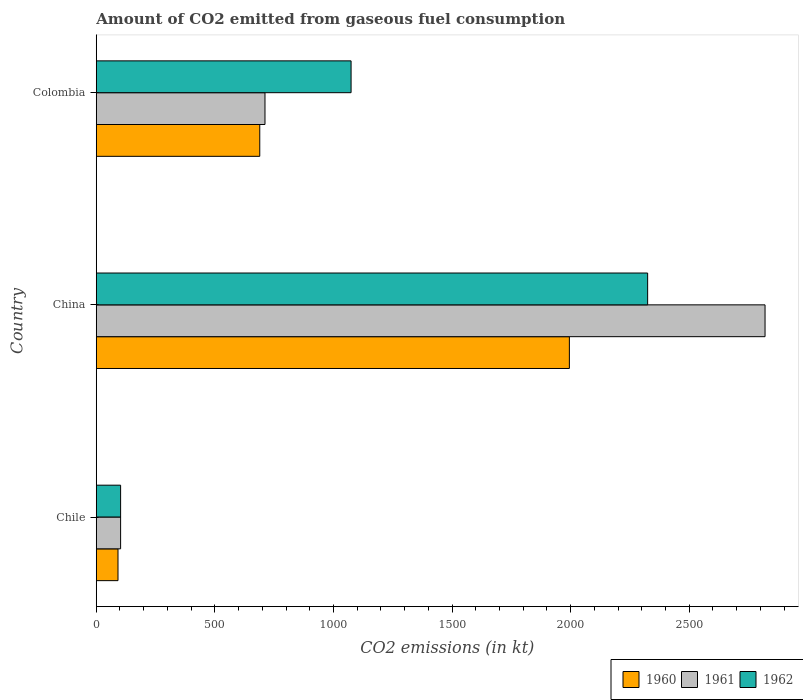How many different coloured bars are there?
Keep it short and to the point. 3. Are the number of bars on each tick of the Y-axis equal?
Your answer should be very brief. Yes. How many bars are there on the 1st tick from the bottom?
Offer a terse response. 3. In how many cases, is the number of bars for a given country not equal to the number of legend labels?
Your answer should be very brief. 0. What is the amount of CO2 emitted in 1962 in China?
Provide a short and direct response. 2324.88. Across all countries, what is the maximum amount of CO2 emitted in 1960?
Offer a terse response. 1994.85. Across all countries, what is the minimum amount of CO2 emitted in 1962?
Your answer should be compact. 102.68. In which country was the amount of CO2 emitted in 1962 maximum?
Your response must be concise. China. In which country was the amount of CO2 emitted in 1962 minimum?
Give a very brief answer. Chile. What is the total amount of CO2 emitted in 1960 in the graph?
Your answer should be very brief. 2775.92. What is the difference between the amount of CO2 emitted in 1961 in Chile and that in Colombia?
Make the answer very short. -608.72. What is the difference between the amount of CO2 emitted in 1960 in China and the amount of CO2 emitted in 1962 in Colombia?
Provide a short and direct response. 920.42. What is the average amount of CO2 emitted in 1962 per country?
Provide a succinct answer. 1167.33. What is the difference between the amount of CO2 emitted in 1961 and amount of CO2 emitted in 1962 in Colombia?
Offer a terse response. -363.03. In how many countries, is the amount of CO2 emitted in 1960 greater than 2200 kt?
Your response must be concise. 0. What is the ratio of the amount of CO2 emitted in 1962 in Chile to that in Colombia?
Ensure brevity in your answer.  0.1. Is the amount of CO2 emitted in 1960 in Chile less than that in Colombia?
Your answer should be very brief. Yes. What is the difference between the highest and the second highest amount of CO2 emitted in 1962?
Ensure brevity in your answer.  1250.45. What is the difference between the highest and the lowest amount of CO2 emitted in 1961?
Offer a very short reply. 2717.25. In how many countries, is the amount of CO2 emitted in 1960 greater than the average amount of CO2 emitted in 1960 taken over all countries?
Offer a terse response. 1. What does the 3rd bar from the bottom in Chile represents?
Give a very brief answer. 1962. Are all the bars in the graph horizontal?
Your answer should be very brief. Yes. How many countries are there in the graph?
Provide a succinct answer. 3. Where does the legend appear in the graph?
Offer a very short reply. Bottom right. How many legend labels are there?
Ensure brevity in your answer.  3. What is the title of the graph?
Your answer should be very brief. Amount of CO2 emitted from gaseous fuel consumption. Does "2005" appear as one of the legend labels in the graph?
Make the answer very short. No. What is the label or title of the X-axis?
Make the answer very short. CO2 emissions (in kt). What is the label or title of the Y-axis?
Keep it short and to the point. Country. What is the CO2 emissions (in kt) in 1960 in Chile?
Offer a terse response. 91.67. What is the CO2 emissions (in kt) of 1961 in Chile?
Make the answer very short. 102.68. What is the CO2 emissions (in kt) in 1962 in Chile?
Give a very brief answer. 102.68. What is the CO2 emissions (in kt) in 1960 in China?
Offer a terse response. 1994.85. What is the CO2 emissions (in kt) of 1961 in China?
Keep it short and to the point. 2819.92. What is the CO2 emissions (in kt) of 1962 in China?
Ensure brevity in your answer.  2324.88. What is the CO2 emissions (in kt) of 1960 in Colombia?
Keep it short and to the point. 689.4. What is the CO2 emissions (in kt) of 1961 in Colombia?
Your response must be concise. 711.4. What is the CO2 emissions (in kt) in 1962 in Colombia?
Offer a very short reply. 1074.43. Across all countries, what is the maximum CO2 emissions (in kt) of 1960?
Provide a short and direct response. 1994.85. Across all countries, what is the maximum CO2 emissions (in kt) of 1961?
Give a very brief answer. 2819.92. Across all countries, what is the maximum CO2 emissions (in kt) in 1962?
Your response must be concise. 2324.88. Across all countries, what is the minimum CO2 emissions (in kt) of 1960?
Offer a terse response. 91.67. Across all countries, what is the minimum CO2 emissions (in kt) of 1961?
Offer a very short reply. 102.68. Across all countries, what is the minimum CO2 emissions (in kt) of 1962?
Make the answer very short. 102.68. What is the total CO2 emissions (in kt) of 1960 in the graph?
Your answer should be very brief. 2775.92. What is the total CO2 emissions (in kt) of 1961 in the graph?
Your answer should be compact. 3634. What is the total CO2 emissions (in kt) of 1962 in the graph?
Give a very brief answer. 3501.99. What is the difference between the CO2 emissions (in kt) of 1960 in Chile and that in China?
Make the answer very short. -1903.17. What is the difference between the CO2 emissions (in kt) in 1961 in Chile and that in China?
Keep it short and to the point. -2717.25. What is the difference between the CO2 emissions (in kt) in 1962 in Chile and that in China?
Your answer should be compact. -2222.2. What is the difference between the CO2 emissions (in kt) of 1960 in Chile and that in Colombia?
Provide a succinct answer. -597.72. What is the difference between the CO2 emissions (in kt) in 1961 in Chile and that in Colombia?
Offer a terse response. -608.72. What is the difference between the CO2 emissions (in kt) in 1962 in Chile and that in Colombia?
Keep it short and to the point. -971.75. What is the difference between the CO2 emissions (in kt) of 1960 in China and that in Colombia?
Provide a succinct answer. 1305.45. What is the difference between the CO2 emissions (in kt) of 1961 in China and that in Colombia?
Your response must be concise. 2108.53. What is the difference between the CO2 emissions (in kt) in 1962 in China and that in Colombia?
Offer a terse response. 1250.45. What is the difference between the CO2 emissions (in kt) in 1960 in Chile and the CO2 emissions (in kt) in 1961 in China?
Your answer should be very brief. -2728.25. What is the difference between the CO2 emissions (in kt) of 1960 in Chile and the CO2 emissions (in kt) of 1962 in China?
Keep it short and to the point. -2233.2. What is the difference between the CO2 emissions (in kt) of 1961 in Chile and the CO2 emissions (in kt) of 1962 in China?
Give a very brief answer. -2222.2. What is the difference between the CO2 emissions (in kt) in 1960 in Chile and the CO2 emissions (in kt) in 1961 in Colombia?
Your response must be concise. -619.72. What is the difference between the CO2 emissions (in kt) in 1960 in Chile and the CO2 emissions (in kt) in 1962 in Colombia?
Your answer should be very brief. -982.76. What is the difference between the CO2 emissions (in kt) in 1961 in Chile and the CO2 emissions (in kt) in 1962 in Colombia?
Provide a succinct answer. -971.75. What is the difference between the CO2 emissions (in kt) of 1960 in China and the CO2 emissions (in kt) of 1961 in Colombia?
Offer a very short reply. 1283.45. What is the difference between the CO2 emissions (in kt) of 1960 in China and the CO2 emissions (in kt) of 1962 in Colombia?
Keep it short and to the point. 920.42. What is the difference between the CO2 emissions (in kt) of 1961 in China and the CO2 emissions (in kt) of 1962 in Colombia?
Offer a very short reply. 1745.49. What is the average CO2 emissions (in kt) in 1960 per country?
Provide a succinct answer. 925.31. What is the average CO2 emissions (in kt) in 1961 per country?
Provide a short and direct response. 1211.33. What is the average CO2 emissions (in kt) in 1962 per country?
Your answer should be compact. 1167.33. What is the difference between the CO2 emissions (in kt) of 1960 and CO2 emissions (in kt) of 1961 in Chile?
Provide a short and direct response. -11. What is the difference between the CO2 emissions (in kt) of 1960 and CO2 emissions (in kt) of 1962 in Chile?
Your answer should be very brief. -11. What is the difference between the CO2 emissions (in kt) in 1961 and CO2 emissions (in kt) in 1962 in Chile?
Ensure brevity in your answer.  0. What is the difference between the CO2 emissions (in kt) in 1960 and CO2 emissions (in kt) in 1961 in China?
Give a very brief answer. -825.08. What is the difference between the CO2 emissions (in kt) in 1960 and CO2 emissions (in kt) in 1962 in China?
Your answer should be compact. -330.03. What is the difference between the CO2 emissions (in kt) of 1961 and CO2 emissions (in kt) of 1962 in China?
Keep it short and to the point. 495.05. What is the difference between the CO2 emissions (in kt) of 1960 and CO2 emissions (in kt) of 1961 in Colombia?
Provide a short and direct response. -22. What is the difference between the CO2 emissions (in kt) of 1960 and CO2 emissions (in kt) of 1962 in Colombia?
Your answer should be compact. -385.04. What is the difference between the CO2 emissions (in kt) of 1961 and CO2 emissions (in kt) of 1962 in Colombia?
Your response must be concise. -363.03. What is the ratio of the CO2 emissions (in kt) of 1960 in Chile to that in China?
Offer a very short reply. 0.05. What is the ratio of the CO2 emissions (in kt) in 1961 in Chile to that in China?
Keep it short and to the point. 0.04. What is the ratio of the CO2 emissions (in kt) in 1962 in Chile to that in China?
Keep it short and to the point. 0.04. What is the ratio of the CO2 emissions (in kt) in 1960 in Chile to that in Colombia?
Provide a short and direct response. 0.13. What is the ratio of the CO2 emissions (in kt) in 1961 in Chile to that in Colombia?
Offer a very short reply. 0.14. What is the ratio of the CO2 emissions (in kt) of 1962 in Chile to that in Colombia?
Your response must be concise. 0.1. What is the ratio of the CO2 emissions (in kt) of 1960 in China to that in Colombia?
Offer a terse response. 2.89. What is the ratio of the CO2 emissions (in kt) of 1961 in China to that in Colombia?
Provide a short and direct response. 3.96. What is the ratio of the CO2 emissions (in kt) in 1962 in China to that in Colombia?
Offer a very short reply. 2.16. What is the difference between the highest and the second highest CO2 emissions (in kt) in 1960?
Your answer should be very brief. 1305.45. What is the difference between the highest and the second highest CO2 emissions (in kt) in 1961?
Ensure brevity in your answer.  2108.53. What is the difference between the highest and the second highest CO2 emissions (in kt) in 1962?
Provide a short and direct response. 1250.45. What is the difference between the highest and the lowest CO2 emissions (in kt) in 1960?
Give a very brief answer. 1903.17. What is the difference between the highest and the lowest CO2 emissions (in kt) of 1961?
Offer a very short reply. 2717.25. What is the difference between the highest and the lowest CO2 emissions (in kt) in 1962?
Provide a short and direct response. 2222.2. 